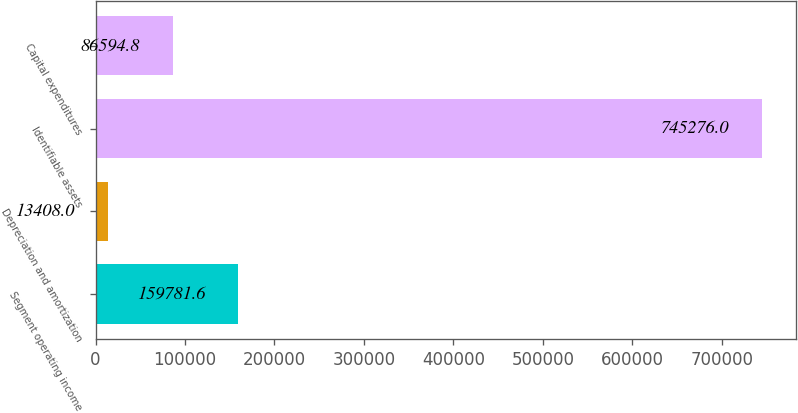Convert chart. <chart><loc_0><loc_0><loc_500><loc_500><bar_chart><fcel>Segment operating income<fcel>Depreciation and amortization<fcel>Identifiable assets<fcel>Capital expenditures<nl><fcel>159782<fcel>13408<fcel>745276<fcel>86594.8<nl></chart> 